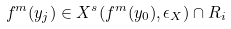<formula> <loc_0><loc_0><loc_500><loc_500>f ^ { m } ( y _ { j } ) \in X ^ { s } ( f ^ { m } ( y _ { 0 } ) , \epsilon _ { X } ) \cap R _ { i }</formula> 